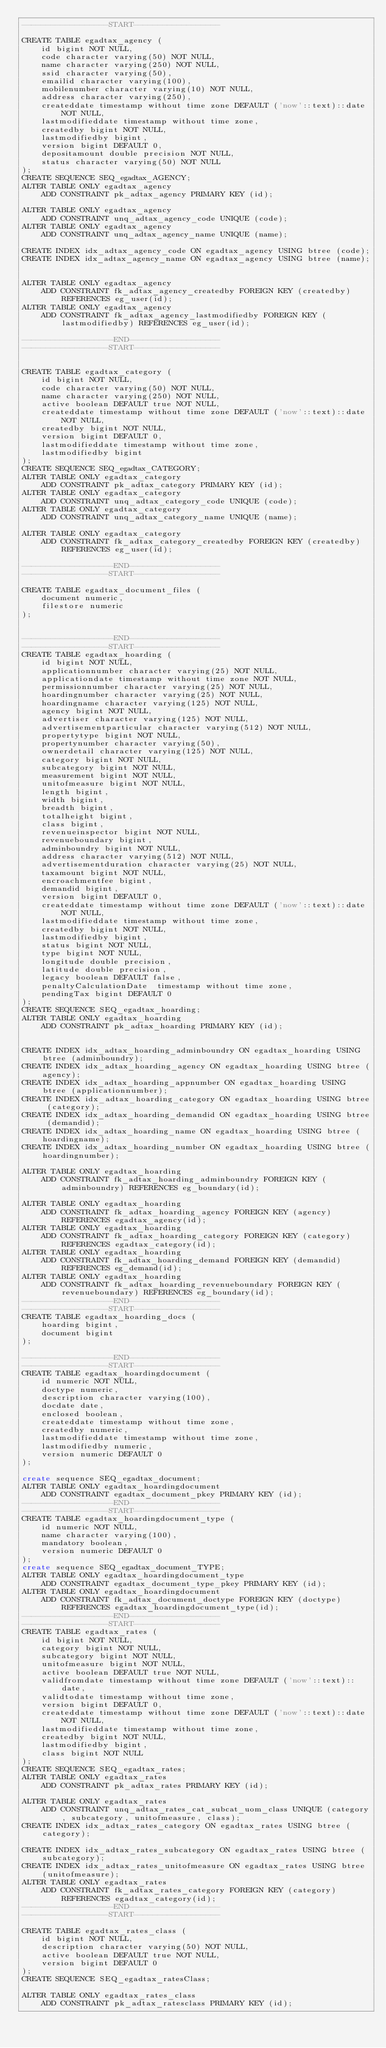Convert code to text. <code><loc_0><loc_0><loc_500><loc_500><_SQL_>------------------START------------------

CREATE TABLE egadtax_agency (
    id bigint NOT NULL,
    code character varying(50) NOT NULL,
    name character varying(250) NOT NULL,
    ssid character varying(50),
    emailid character varying(100),
    mobilenumber character varying(10) NOT NULL,
    address character varying(250),
    createddate timestamp without time zone DEFAULT ('now'::text)::date NOT NULL,
    lastmodifieddate timestamp without time zone,
    createdby bigint NOT NULL,
    lastmodifiedby bigint,
    version bigint DEFAULT 0,
    depositamount double precision NOT NULL,
    status character varying(50) NOT NULL
);
CREATE SEQUENCE SEQ_egadtax_AGENCY;
ALTER TABLE ONLY egadtax_agency
    ADD CONSTRAINT pk_adtax_agency PRIMARY KEY (id);

ALTER TABLE ONLY egadtax_agency
    ADD CONSTRAINT unq_adtax_agency_code UNIQUE (code);
ALTER TABLE ONLY egadtax_agency
    ADD CONSTRAINT unq_adtax_agency_name UNIQUE (name);

CREATE INDEX idx_adtax_agency_code ON egadtax_agency USING btree (code);
CREATE INDEX idx_adtax_agency_name ON egadtax_agency USING btree (name);


ALTER TABLE ONLY egadtax_agency
    ADD CONSTRAINT fk_adtax_agency_createdby FOREIGN KEY (createdby) REFERENCES eg_user(id);
ALTER TABLE ONLY egadtax_agency
    ADD CONSTRAINT fk_adtax_agency_lastmodifiedby FOREIGN KEY (lastmodifiedby) REFERENCES eg_user(id);

-------------------END-------------------
------------------START------------------


CREATE TABLE egadtax_category (
    id bigint NOT NULL,
    code character varying(50) NOT NULL,
    name character varying(250) NOT NULL,
    active boolean DEFAULT true NOT NULL,
    createddate timestamp without time zone DEFAULT ('now'::text)::date NOT NULL,
    createdby bigint NOT NULL,
    version bigint DEFAULT 0,
    lastmodifieddate timestamp without time zone,
    lastmodifiedby bigint
);
CREATE SEQUENCE SEQ_egadtax_CATEGORY;
ALTER TABLE ONLY egadtax_category
    ADD CONSTRAINT pk_adtax_category PRIMARY KEY (id);
ALTER TABLE ONLY egadtax_category
    ADD CONSTRAINT unq_adtax_category_code UNIQUE (code);
ALTER TABLE ONLY egadtax_category
    ADD CONSTRAINT unq_adtax_category_name UNIQUE (name);

ALTER TABLE ONLY egadtax_category
    ADD CONSTRAINT fk_adtax_category_createdby FOREIGN KEY (createdby) REFERENCES eg_user(id);

-------------------END-------------------
------------------START------------------

CREATE TABLE egadtax_document_files (
    document numeric,
    filestore numeric
);


-------------------END-------------------
------------------START------------------
CREATE TABLE egadtax_hoarding (
    id bigint NOT NULL,
    applicationnumber character varying(25) NOT NULL,
    applicationdate timestamp without time zone NOT NULL,
    permissionnumber character varying(25) NOT NULL,
    hoardingnumber character varying(25) NOT NULL,
    hoardingname character varying(125) NOT NULL,
    agency bigint NOT NULL,
    advertiser character varying(125) NOT NULL,
    advertisementparticular character varying(512) NOT NULL,
    propertytype bigint NOT NULL,
    propertynumber character varying(50),
    ownerdetail character varying(125) NOT NULL,
    category bigint NOT NULL,
    subcategory bigint NOT NULL,
    measurement bigint NOT NULL,
    unitofmeasure bigint NOT NULL,
    length bigint,
    width bigint,
    breadth bigint,
    totalheight bigint,
    class bigint,
    revenueinspector bigint NOT NULL,
    revenueboundary bigint,
    adminboundry bigint NOT NULL,
    address character varying(512) NOT NULL,
    advertisementduration character varying(25) NOT NULL,
    taxamount bigint NOT NULL,
    encroachmentfee bigint,
    demandid bigint,
    version bigint DEFAULT 0,
    createddate timestamp without time zone DEFAULT ('now'::text)::date NOT NULL,
    lastmodifieddate timestamp without time zone,
    createdby bigint NOT NULL,
    lastmodifiedby bigint,
    status bigint NOT NULL,
    type bigint NOT NULL,
    longitude double precision,
    latitude double precision,
    legacy boolean DEFAULT false,
    penaltyCalculationDate  timestamp without time zone,
    pendingTax bigint DEFAULT 0
);
CREATE SEQUENCE SEQ_egadtax_hoarding;
ALTER TABLE ONLY egadtax_hoarding
    ADD CONSTRAINT pk_adtax_hoarding PRIMARY KEY (id);


CREATE INDEX idx_adtax_hoarding_adminboundry ON egadtax_hoarding USING btree (adminboundry);
CREATE INDEX idx_adtax_hoarding_agency ON egadtax_hoarding USING btree (agency);
CREATE INDEX idx_adtax_hoarding_appnumber ON egadtax_hoarding USING btree (applicationnumber);
CREATE INDEX idx_adtax_hoarding_category ON egadtax_hoarding USING btree (category);
CREATE INDEX idx_adtax_hoarding_demandid ON egadtax_hoarding USING btree (demandid);
CREATE INDEX idx_adtax_hoarding_name ON egadtax_hoarding USING btree (hoardingname);
CREATE INDEX idx_adtax_hoarding_number ON egadtax_hoarding USING btree (hoardingnumber);

ALTER TABLE ONLY egadtax_hoarding
    ADD CONSTRAINT fk_adtax_hoarding_adminboundry FOREIGN KEY (adminboundry) REFERENCES eg_boundary(id);

ALTER TABLE ONLY egadtax_hoarding
    ADD CONSTRAINT fk_adtax_hoarding_agency FOREIGN KEY (agency) REFERENCES egadtax_agency(id);
ALTER TABLE ONLY egadtax_hoarding
    ADD CONSTRAINT fk_adtax_hoarding_category FOREIGN KEY (category) REFERENCES egadtax_category(id);
ALTER TABLE ONLY egadtax_hoarding
    ADD CONSTRAINT fk_adtax_hoarding_demand FOREIGN KEY (demandid) REFERENCES eg_demand(id);
ALTER TABLE ONLY egadtax_hoarding
    ADD CONSTRAINT fk_adtax_hoarding_revenueboundary FOREIGN KEY (revenueboundary) REFERENCES eg_boundary(id);
-------------------END-------------------
------------------START------------------
CREATE TABLE egadtax_hoarding_docs (
    hoarding bigint,
    document bigint
);

-------------------END-------------------
------------------START------------------
CREATE TABLE egadtax_hoardingdocument (
    id numeric NOT NULL,
    doctype numeric,
    description character varying(100),
    docdate date,
    enclosed boolean,
    createddate timestamp without time zone,
    createdby numeric,
    lastmodifieddate timestamp without time zone,
    lastmodifiedby numeric,
    version numeric DEFAULT 0
);

create sequence SEQ_egadtax_document;
ALTER TABLE ONLY egadtax_hoardingdocument
    ADD CONSTRAINT egadtax_document_pkey PRIMARY KEY (id);
-------------------END-------------------
------------------START------------------
CREATE TABLE egadtax_hoardingdocument_type (
    id numeric NOT NULL,
    name character varying(100),
    mandatory boolean,
    version numeric DEFAULT 0
);
create sequence SEQ_egadtax_document_TYPE;
ALTER TABLE ONLY egadtax_hoardingdocument_type
    ADD CONSTRAINT egadtax_document_type_pkey PRIMARY KEY (id);
ALTER TABLE ONLY egadtax_hoardingdocument
    ADD CONSTRAINT fk_adtax_document_doctype FOREIGN KEY (doctype) REFERENCES egadtax_hoardingdocument_type(id);
-------------------END-------------------
------------------START------------------
CREATE TABLE egadtax_rates (
    id bigint NOT NULL,
    category bigint NOT NULL,
    subcategory bigint NOT NULL,
    unitofmeasure bigint NOT NULL,
    active boolean DEFAULT true NOT NULL,
    validfromdate timestamp without time zone DEFAULT ('now'::text)::date,
    validtodate timestamp without time zone,
    version bigint DEFAULT 0,
    createddate timestamp without time zone DEFAULT ('now'::text)::date NOT NULL,
    lastmodifieddate timestamp without time zone,
    createdby bigint NOT NULL,
    lastmodifiedby bigint,
    class bigint NOT NULL
);
CREATE SEQUENCE SEQ_egadtax_rates;
ALTER TABLE ONLY egadtax_rates
    ADD CONSTRAINT pk_adtax_rates PRIMARY KEY (id);

ALTER TABLE ONLY egadtax_rates
    ADD CONSTRAINT unq_adtax_rates_cat_subcat_uom_class UNIQUE (category, subcategory, unitofmeasure, class);
CREATE INDEX idx_adtax_rates_category ON egadtax_rates USING btree (category);

CREATE INDEX idx_adtax_rates_subcategory ON egadtax_rates USING btree (subcategory);
CREATE INDEX idx_adtax_rates_unitofmeasure ON egadtax_rates USING btree (unitofmeasure);
ALTER TABLE ONLY egadtax_rates
    ADD CONSTRAINT fk_adtax_rates_category FOREIGN KEY (category) REFERENCES egadtax_category(id);
-------------------END-------------------
------------------START------------------

CREATE TABLE egadtax_rates_class (
    id bigint NOT NULL,
    description character varying(50) NOT NULL,
    active boolean DEFAULT true NOT NULL,
    version bigint DEFAULT 0
);
CREATE SEQUENCE SEQ_egadtax_ratesClass;

ALTER TABLE ONLY egadtax_rates_class
    ADD CONSTRAINT pk_adtax_ratesclass PRIMARY KEY (id);
</code> 